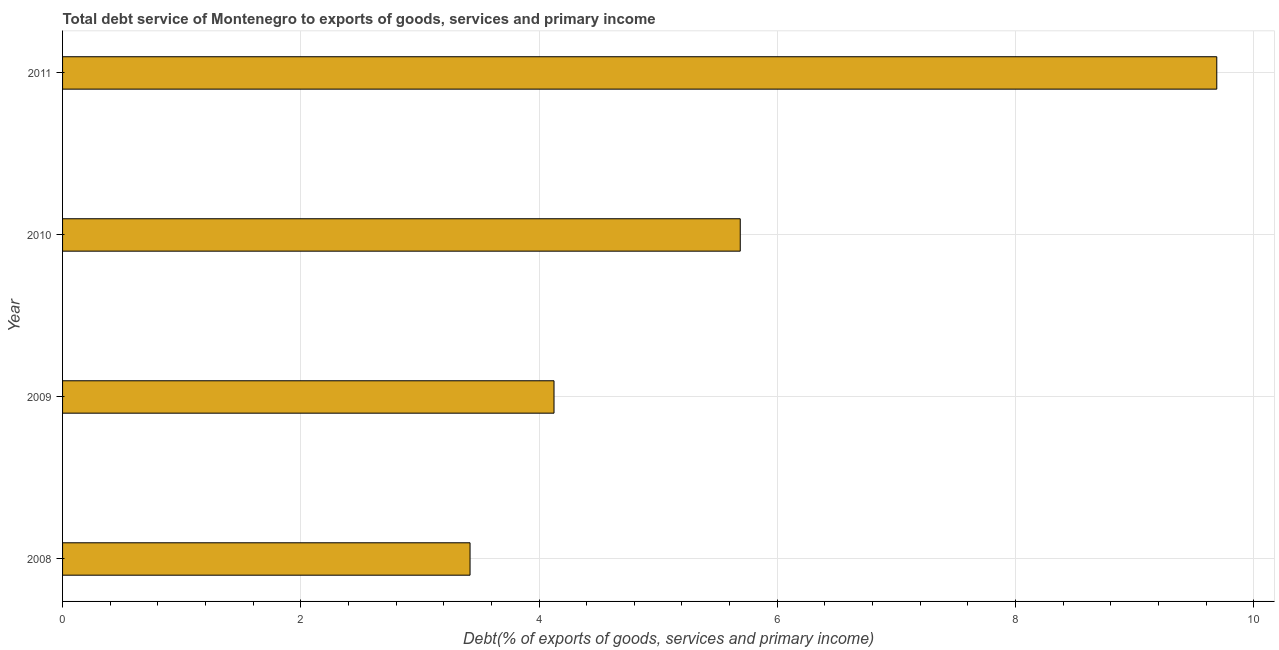Does the graph contain grids?
Your response must be concise. Yes. What is the title of the graph?
Provide a short and direct response. Total debt service of Montenegro to exports of goods, services and primary income. What is the label or title of the X-axis?
Your answer should be compact. Debt(% of exports of goods, services and primary income). What is the total debt service in 2008?
Ensure brevity in your answer.  3.42. Across all years, what is the maximum total debt service?
Offer a very short reply. 9.69. Across all years, what is the minimum total debt service?
Ensure brevity in your answer.  3.42. What is the sum of the total debt service?
Provide a short and direct response. 22.93. What is the difference between the total debt service in 2009 and 2011?
Make the answer very short. -5.56. What is the average total debt service per year?
Provide a short and direct response. 5.73. What is the median total debt service?
Your answer should be very brief. 4.91. What is the ratio of the total debt service in 2010 to that in 2011?
Give a very brief answer. 0.59. Is the total debt service in 2008 less than that in 2009?
Your answer should be very brief. Yes. Is the difference between the total debt service in 2008 and 2010 greater than the difference between any two years?
Your answer should be compact. No. What is the difference between the highest and the second highest total debt service?
Offer a very short reply. 4. Is the sum of the total debt service in 2008 and 2011 greater than the maximum total debt service across all years?
Keep it short and to the point. Yes. What is the difference between the highest and the lowest total debt service?
Ensure brevity in your answer.  6.27. In how many years, is the total debt service greater than the average total debt service taken over all years?
Offer a terse response. 1. What is the difference between two consecutive major ticks on the X-axis?
Give a very brief answer. 2. What is the Debt(% of exports of goods, services and primary income) of 2008?
Provide a succinct answer. 3.42. What is the Debt(% of exports of goods, services and primary income) in 2009?
Give a very brief answer. 4.13. What is the Debt(% of exports of goods, services and primary income) in 2010?
Your response must be concise. 5.69. What is the Debt(% of exports of goods, services and primary income) of 2011?
Give a very brief answer. 9.69. What is the difference between the Debt(% of exports of goods, services and primary income) in 2008 and 2009?
Your answer should be very brief. -0.7. What is the difference between the Debt(% of exports of goods, services and primary income) in 2008 and 2010?
Make the answer very short. -2.27. What is the difference between the Debt(% of exports of goods, services and primary income) in 2008 and 2011?
Offer a terse response. -6.27. What is the difference between the Debt(% of exports of goods, services and primary income) in 2009 and 2010?
Your answer should be very brief. -1.56. What is the difference between the Debt(% of exports of goods, services and primary income) in 2009 and 2011?
Ensure brevity in your answer.  -5.56. What is the difference between the Debt(% of exports of goods, services and primary income) in 2010 and 2011?
Give a very brief answer. -4. What is the ratio of the Debt(% of exports of goods, services and primary income) in 2008 to that in 2009?
Provide a short and direct response. 0.83. What is the ratio of the Debt(% of exports of goods, services and primary income) in 2008 to that in 2010?
Your answer should be compact. 0.6. What is the ratio of the Debt(% of exports of goods, services and primary income) in 2008 to that in 2011?
Ensure brevity in your answer.  0.35. What is the ratio of the Debt(% of exports of goods, services and primary income) in 2009 to that in 2010?
Your response must be concise. 0.72. What is the ratio of the Debt(% of exports of goods, services and primary income) in 2009 to that in 2011?
Offer a terse response. 0.43. What is the ratio of the Debt(% of exports of goods, services and primary income) in 2010 to that in 2011?
Your answer should be very brief. 0.59. 